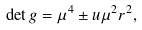<formula> <loc_0><loc_0><loc_500><loc_500>\det g = \mu ^ { 4 } \pm u \mu ^ { 2 } r ^ { 2 } ,</formula> 